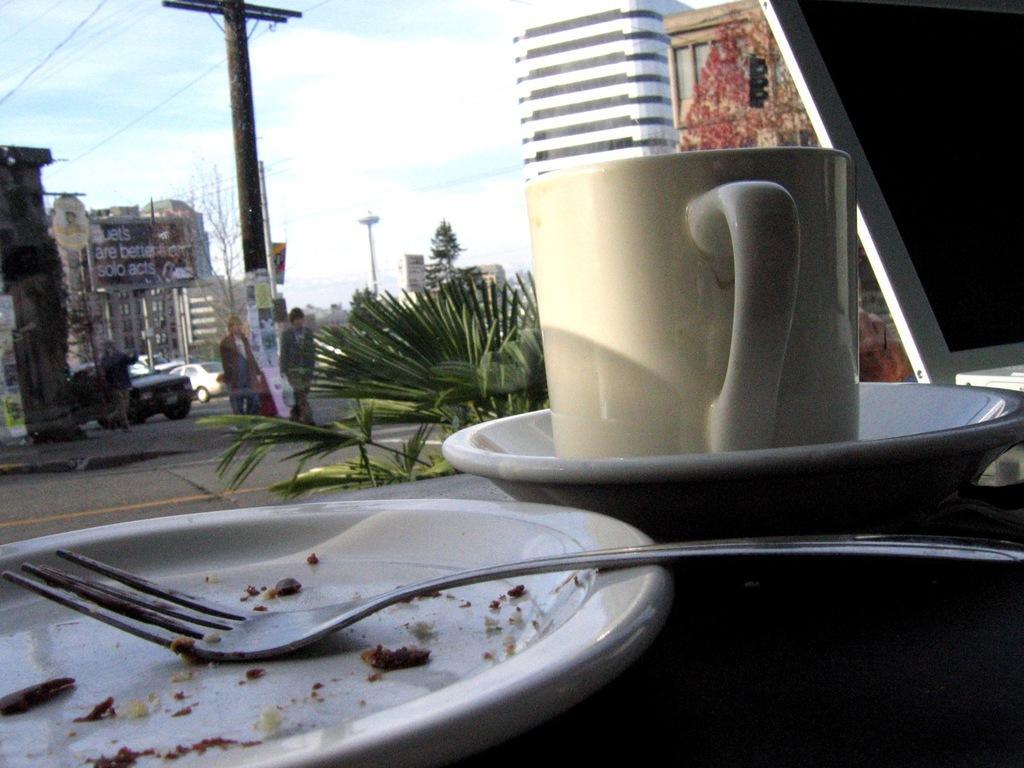Can you describe this image briefly? In this image in front there is a plate, fork, cup, succor and laptop on the table. In the center of the image there are cars on the road. There are people walking on the road. There are plants. In the background of the image there are buildings, trees, street lights and sky. 